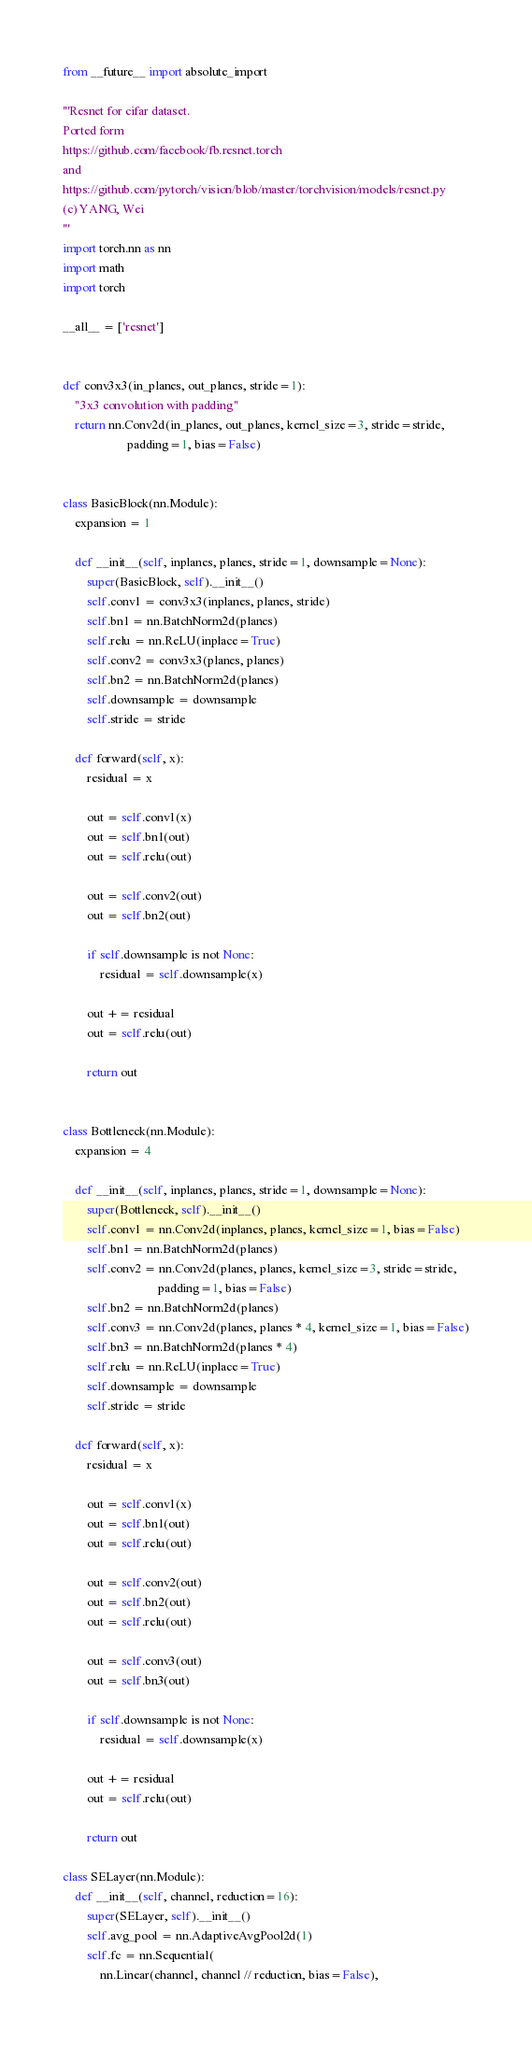<code> <loc_0><loc_0><loc_500><loc_500><_Python_>from __future__ import absolute_import

'''Resnet for cifar dataset.
Ported form
https://github.com/facebook/fb.resnet.torch
and
https://github.com/pytorch/vision/blob/master/torchvision/models/resnet.py
(c) YANG, Wei
'''
import torch.nn as nn
import math
import torch

__all__ = ['resnet']


def conv3x3(in_planes, out_planes, stride=1):
    "3x3 convolution with padding"
    return nn.Conv2d(in_planes, out_planes, kernel_size=3, stride=stride,
                     padding=1, bias=False)


class BasicBlock(nn.Module):
    expansion = 1

    def __init__(self, inplanes, planes, stride=1, downsample=None):
        super(BasicBlock, self).__init__()
        self.conv1 = conv3x3(inplanes, planes, stride)
        self.bn1 = nn.BatchNorm2d(planes)
        self.relu = nn.ReLU(inplace=True)
        self.conv2 = conv3x3(planes, planes)
        self.bn2 = nn.BatchNorm2d(planes)
        self.downsample = downsample
        self.stride = stride

    def forward(self, x):
        residual = x

        out = self.conv1(x)
        out = self.bn1(out)
        out = self.relu(out)

        out = self.conv2(out)
        out = self.bn2(out)

        if self.downsample is not None:
            residual = self.downsample(x)

        out += residual
        out = self.relu(out)

        return out


class Bottleneck(nn.Module):
    expansion = 4

    def __init__(self, inplanes, planes, stride=1, downsample=None):
        super(Bottleneck, self).__init__()
        self.conv1 = nn.Conv2d(inplanes, planes, kernel_size=1, bias=False)
        self.bn1 = nn.BatchNorm2d(planes)
        self.conv2 = nn.Conv2d(planes, planes, kernel_size=3, stride=stride,
                               padding=1, bias=False)
        self.bn2 = nn.BatchNorm2d(planes)
        self.conv3 = nn.Conv2d(planes, planes * 4, kernel_size=1, bias=False)
        self.bn3 = nn.BatchNorm2d(planes * 4)
        self.relu = nn.ReLU(inplace=True)
        self.downsample = downsample
        self.stride = stride

    def forward(self, x):
        residual = x

        out = self.conv1(x)
        out = self.bn1(out)
        out = self.relu(out)

        out = self.conv2(out)
        out = self.bn2(out)
        out = self.relu(out)

        out = self.conv3(out)
        out = self.bn3(out)

        if self.downsample is not None:
            residual = self.downsample(x)

        out += residual
        out = self.relu(out)

        return out

class SELayer(nn.Module):
    def __init__(self, channel, reduction=16):
        super(SELayer, self).__init__()
        self.avg_pool = nn.AdaptiveAvgPool2d(1)
        self.fc = nn.Sequential(
            nn.Linear(channel, channel // reduction, bias=False),</code> 